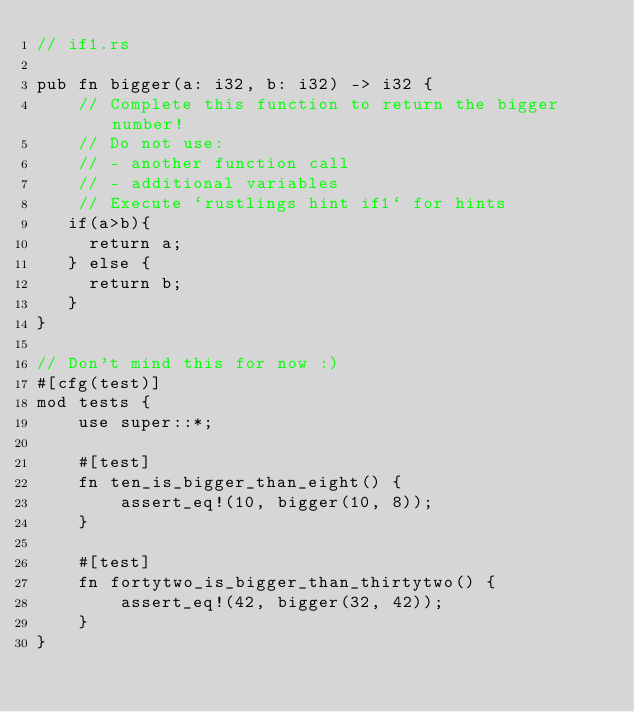Convert code to text. <code><loc_0><loc_0><loc_500><loc_500><_Rust_>// if1.rs

pub fn bigger(a: i32, b: i32) -> i32 {
    // Complete this function to return the bigger number!
    // Do not use:
    // - another function call
    // - additional variables
    // Execute `rustlings hint if1` for hints
   if(a>b){
     return a;  
   } else {
     return b;
   }
}

// Don't mind this for now :)
#[cfg(test)]
mod tests {
    use super::*;

    #[test]
    fn ten_is_bigger_than_eight() {
        assert_eq!(10, bigger(10, 8));
    }

    #[test]
    fn fortytwo_is_bigger_than_thirtytwo() {
        assert_eq!(42, bigger(32, 42));
    }
}
</code> 